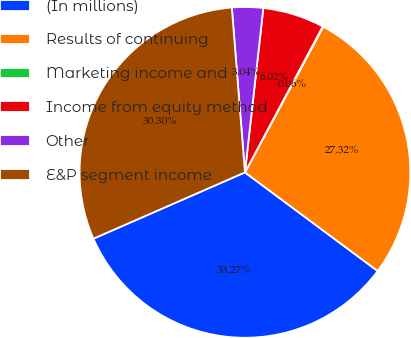Convert chart. <chart><loc_0><loc_0><loc_500><loc_500><pie_chart><fcel>(In millions)<fcel>Results of continuing<fcel>Marketing income and<fcel>Income from equity method<fcel>Other<fcel>E&P segment income<nl><fcel>33.27%<fcel>27.32%<fcel>0.06%<fcel>6.02%<fcel>3.04%<fcel>30.3%<nl></chart> 